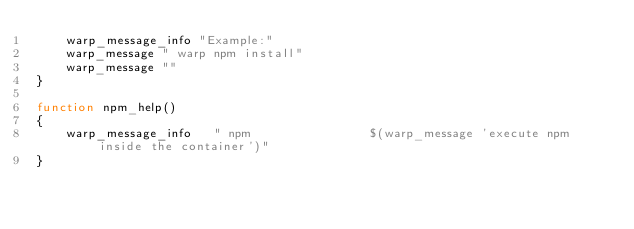<code> <loc_0><loc_0><loc_500><loc_500><_Bash_>    warp_message_info "Example:"
    warp_message " warp npm install"
    warp_message ""    
}

function npm_help()
{
    warp_message_info   " npm                $(warp_message 'execute npm inside the container')"
}
</code> 